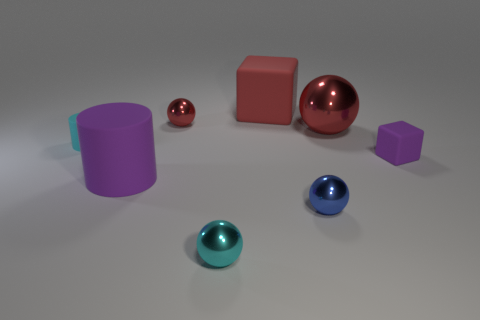Subtract all small cyan spheres. How many spheres are left? 3 Subtract all cubes. How many objects are left? 6 Add 2 purple rubber cubes. How many objects exist? 10 Subtract all red spheres. How many spheres are left? 2 Subtract 0 brown cubes. How many objects are left? 8 Subtract 1 blocks. How many blocks are left? 1 Subtract all purple cylinders. Subtract all brown balls. How many cylinders are left? 1 Subtract all purple cylinders. How many blue spheres are left? 1 Subtract all tiny blue balls. Subtract all cylinders. How many objects are left? 5 Add 3 red shiny objects. How many red shiny objects are left? 5 